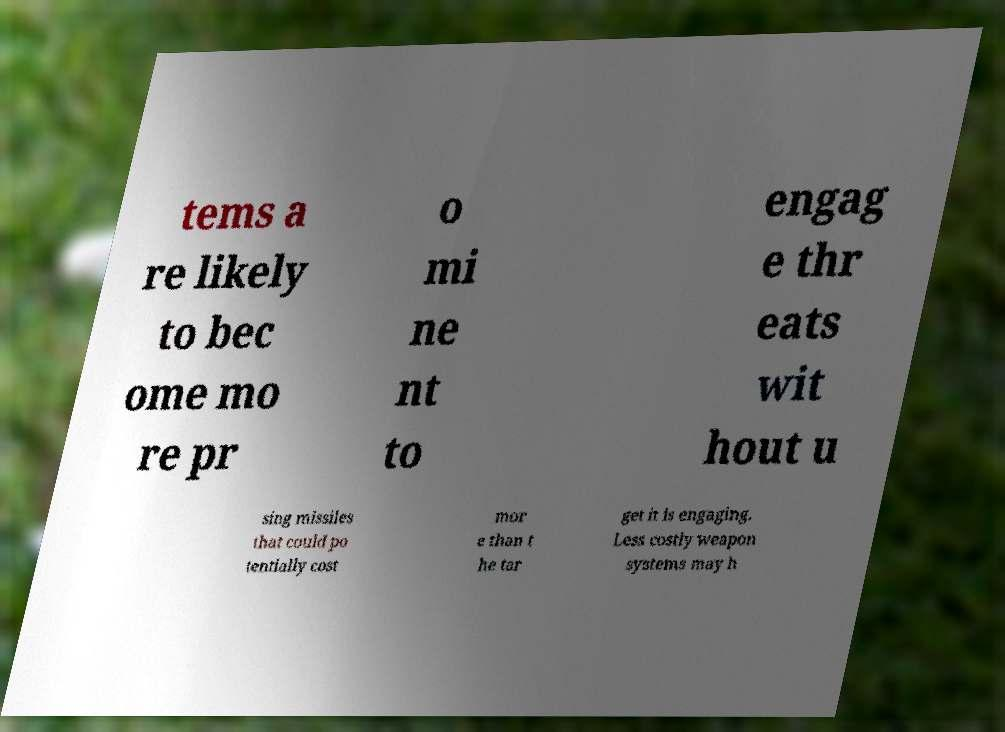For documentation purposes, I need the text within this image transcribed. Could you provide that? tems a re likely to bec ome mo re pr o mi ne nt to engag e thr eats wit hout u sing missiles that could po tentially cost mor e than t he tar get it is engaging. Less costly weapon systems may h 